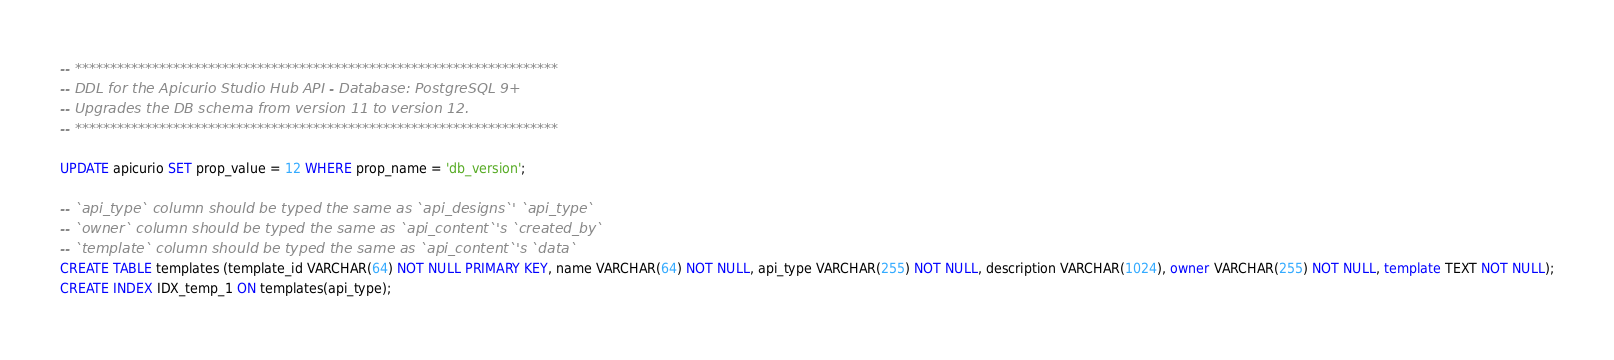Convert code to text. <code><loc_0><loc_0><loc_500><loc_500><_SQL_>-- *********************************************************************
-- DDL for the Apicurio Studio Hub API - Database: PostgreSQL 9+
-- Upgrades the DB schema from version 11 to version 12.
-- *********************************************************************

UPDATE apicurio SET prop_value = 12 WHERE prop_name = 'db_version';

-- `api_type` column should be typed the same as `api_designs`' `api_type`
-- `owner` column should be typed the same as `api_content`'s `created_by`
-- `template` column should be typed the same as `api_content`'s `data`
CREATE TABLE templates (template_id VARCHAR(64) NOT NULL PRIMARY KEY, name VARCHAR(64) NOT NULL, api_type VARCHAR(255) NOT NULL, description VARCHAR(1024), owner VARCHAR(255) NOT NULL, template TEXT NOT NULL);
CREATE INDEX IDX_temp_1 ON templates(api_type);
</code> 